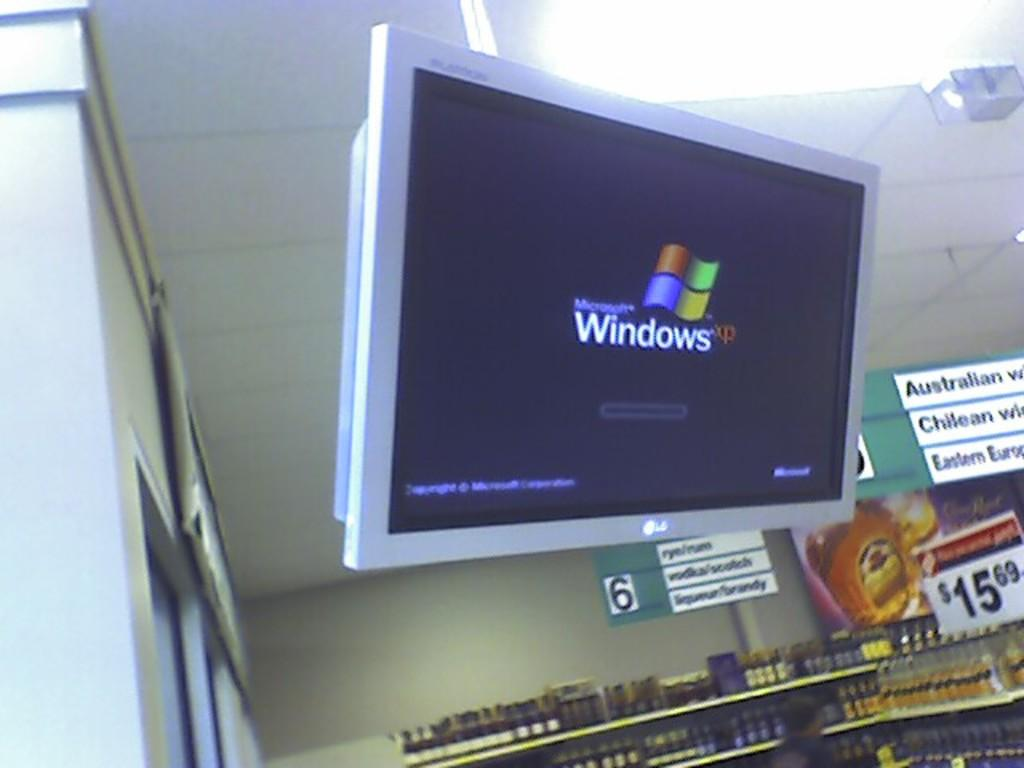Provide a one-sentence caption for the provided image. A monitor showing Microsoft Windows XP boot screen. 